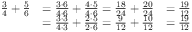<formula> <loc_0><loc_0><loc_500><loc_500>{ \begin{array} { r l r } { { \frac { 3 } { 4 } } + { \frac { 5 } { 6 } } } & { = { \frac { 3 \cdot 6 } { 4 \cdot 6 } } + { \frac { 4 \cdot 5 } { 4 \cdot 6 } } = { \frac { 1 8 } { 2 4 } } + { \frac { 2 0 } { 2 4 } } } & { = { \frac { 1 9 } { 1 2 } } } \\ & { = { \frac { 3 \cdot 3 } { 4 \cdot 3 } } + { \frac { 2 \cdot 5 } { 2 \cdot 6 } } = { \frac { 9 } { 1 2 } } + { \frac { 1 0 } { 1 2 } } } & { = { \frac { 1 9 } { 1 2 } } } \end{array} }</formula> 